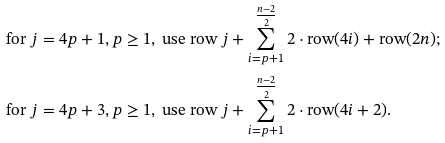Convert formula to latex. <formula><loc_0><loc_0><loc_500><loc_500>& \text {for } j = 4 p + 1 , p \geq 1 , \text { use row } j + \sum _ { i = p + 1 } ^ { \frac { n - 2 } { 2 } } 2 \cdot \text {row} ( 4 i ) + \text {row} ( 2 n ) ; \\ & \text {for } j = 4 p + 3 , p \geq 1 , \text { use row } j + \sum _ { i = p + 1 } ^ { \frac { n - 2 } { 2 } } 2 \cdot \text {row} ( 4 i + 2 ) .</formula> 